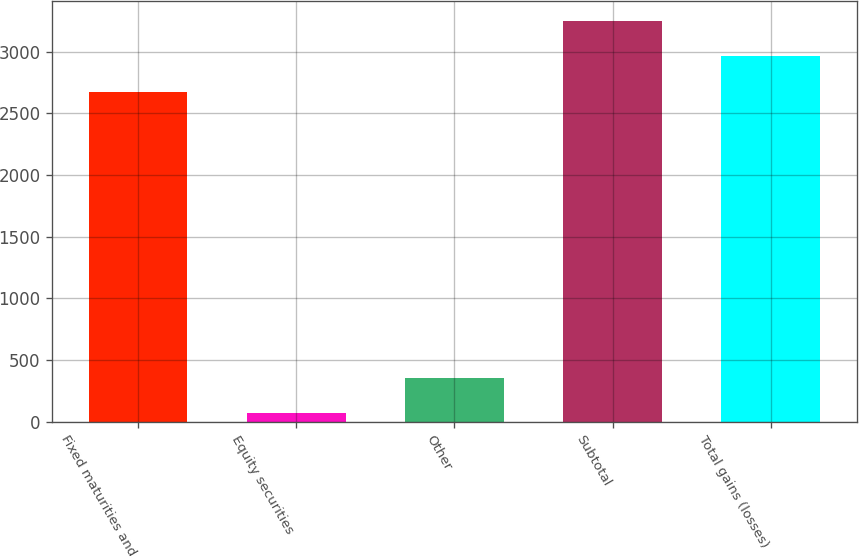Convert chart. <chart><loc_0><loc_0><loc_500><loc_500><bar_chart><fcel>Fixed maturities and<fcel>Equity securities<fcel>Other<fcel>Subtotal<fcel>Total gains (losses)<nl><fcel>2676<fcel>68<fcel>354.9<fcel>3249.8<fcel>2962.9<nl></chart> 